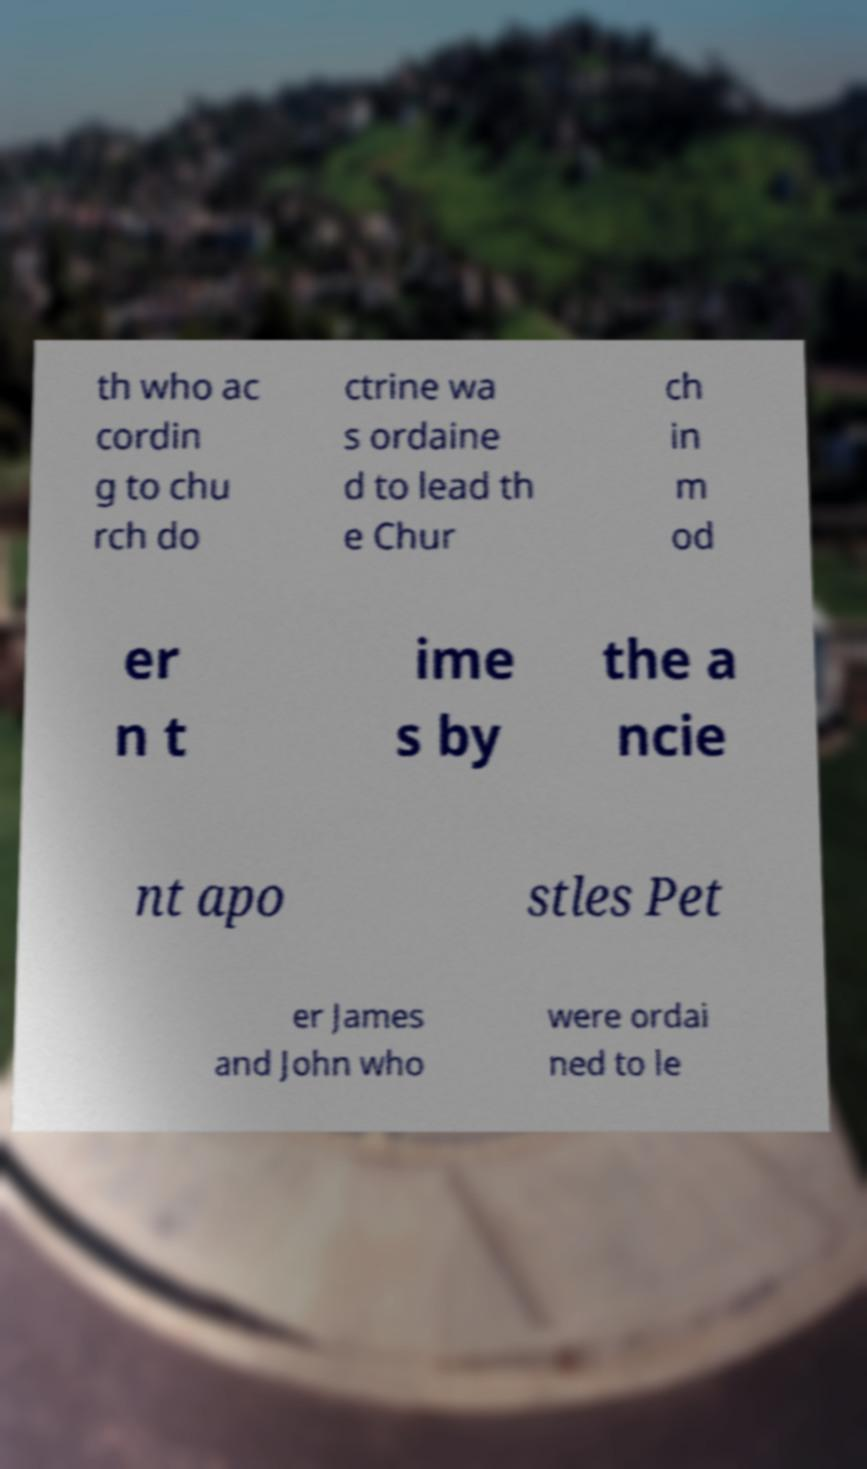Could you assist in decoding the text presented in this image and type it out clearly? th who ac cordin g to chu rch do ctrine wa s ordaine d to lead th e Chur ch in m od er n t ime s by the a ncie nt apo stles Pet er James and John who were ordai ned to le 